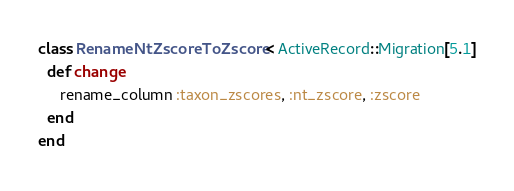<code> <loc_0><loc_0><loc_500><loc_500><_Ruby_>class RenameNtZscoreToZscore < ActiveRecord::Migration[5.1]
  def change
     rename_column :taxon_zscores, :nt_zscore, :zscore
  end
end
</code> 